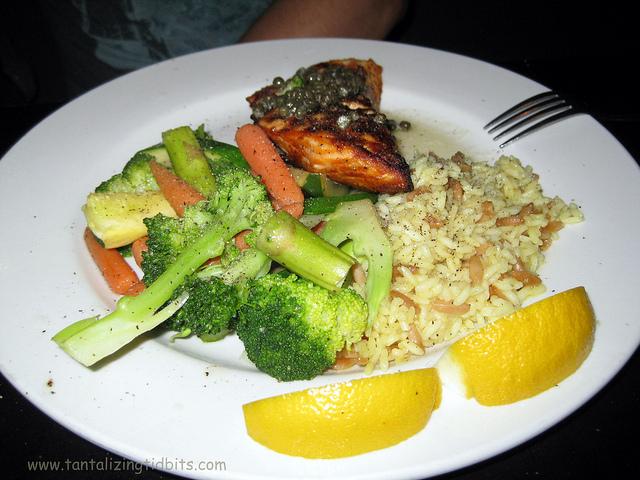How many different vegetables does this dish contain?
Answer briefly. 3. Is this vegetarian friendly?
Give a very brief answer. No. What is the utensil shown?
Concise answer only. Fork. How many prongs does the fork have?
Give a very brief answer. 4. What type of salad is this?
Answer briefly. Veggie. What color of rice is on this white plate?
Quick response, please. Yellow. Why are lemons served with this meal?
Concise answer only. Yes. Are the lemons yellow?
Write a very short answer. Yes. What is the sauce on top of the fish?
Quick response, please. Caviar. 